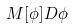<formula> <loc_0><loc_0><loc_500><loc_500>M [ \phi ] D \phi</formula> 